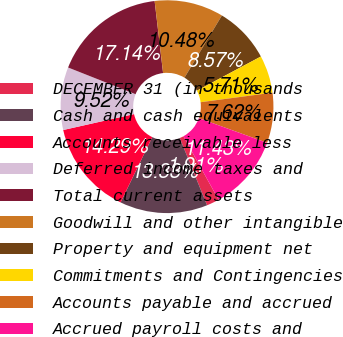Convert chart to OTSL. <chart><loc_0><loc_0><loc_500><loc_500><pie_chart><fcel>DECEMBER 31 (in thousands<fcel>Cash and cash equivalents<fcel>Accounts receivable less<fcel>Deferred income taxes and<fcel>Total current assets<fcel>Goodwill and other intangible<fcel>Property and equipment net<fcel>Commitments and Contingencies<fcel>Accounts payable and accrued<fcel>Accrued payroll costs and<nl><fcel>1.91%<fcel>13.33%<fcel>14.29%<fcel>9.52%<fcel>17.14%<fcel>10.48%<fcel>8.57%<fcel>5.71%<fcel>7.62%<fcel>11.43%<nl></chart> 